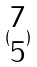<formula> <loc_0><loc_0><loc_500><loc_500>( \begin{matrix} 7 \\ 5 \end{matrix} )</formula> 